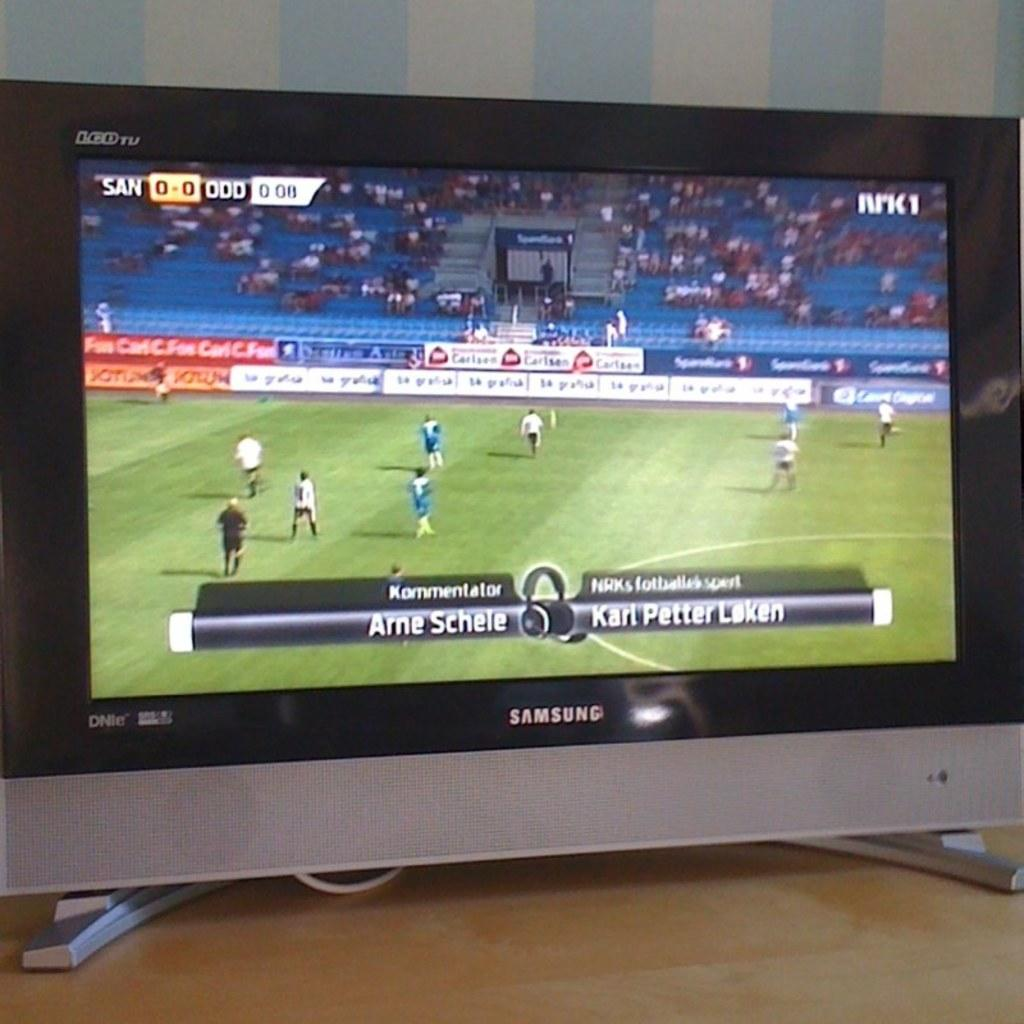<image>
Offer a succinct explanation of the picture presented. A silver and black flat screen that says Samsung is showing a soccer game. 